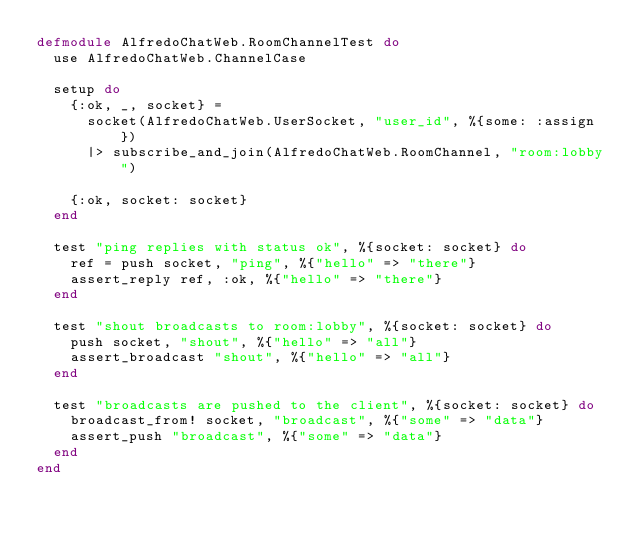<code> <loc_0><loc_0><loc_500><loc_500><_Elixir_>defmodule AlfredoChatWeb.RoomChannelTest do
  use AlfredoChatWeb.ChannelCase

  setup do
    {:ok, _, socket} =
      socket(AlfredoChatWeb.UserSocket, "user_id", %{some: :assign})
      |> subscribe_and_join(AlfredoChatWeb.RoomChannel, "room:lobby")

    {:ok, socket: socket}
  end

  test "ping replies with status ok", %{socket: socket} do
    ref = push socket, "ping", %{"hello" => "there"}
    assert_reply ref, :ok, %{"hello" => "there"}
  end

  test "shout broadcasts to room:lobby", %{socket: socket} do
    push socket, "shout", %{"hello" => "all"}
    assert_broadcast "shout", %{"hello" => "all"}
  end

  test "broadcasts are pushed to the client", %{socket: socket} do
    broadcast_from! socket, "broadcast", %{"some" => "data"}
    assert_push "broadcast", %{"some" => "data"}
  end
end
</code> 